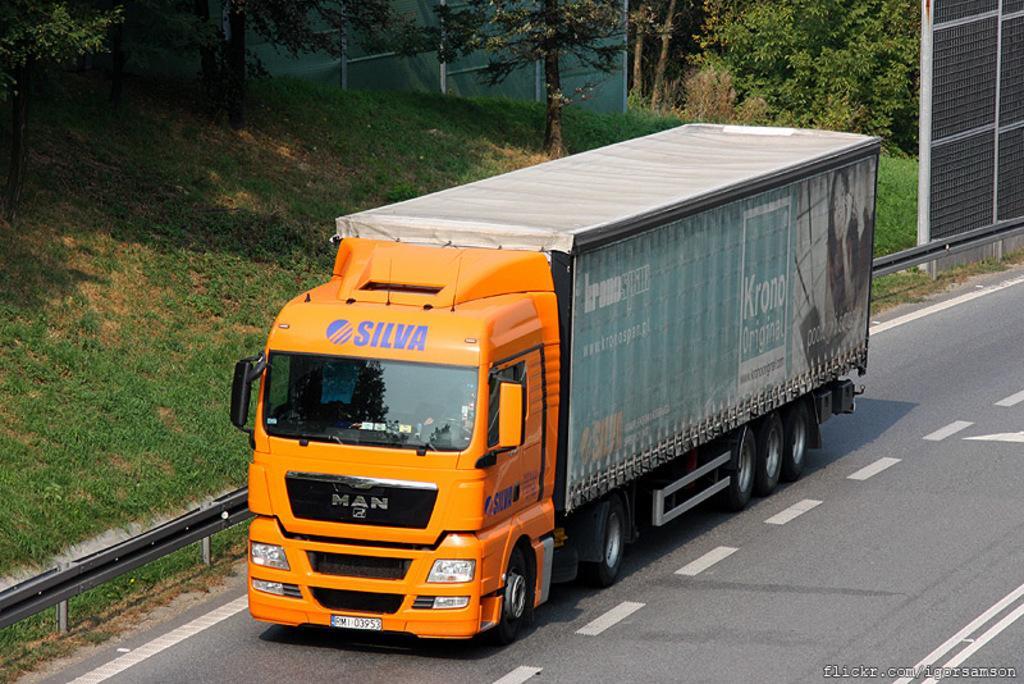Could you give a brief overview of what you see in this image? In the picture there is a truck moving on the road, beside the truck there is some greenery with few trees. 